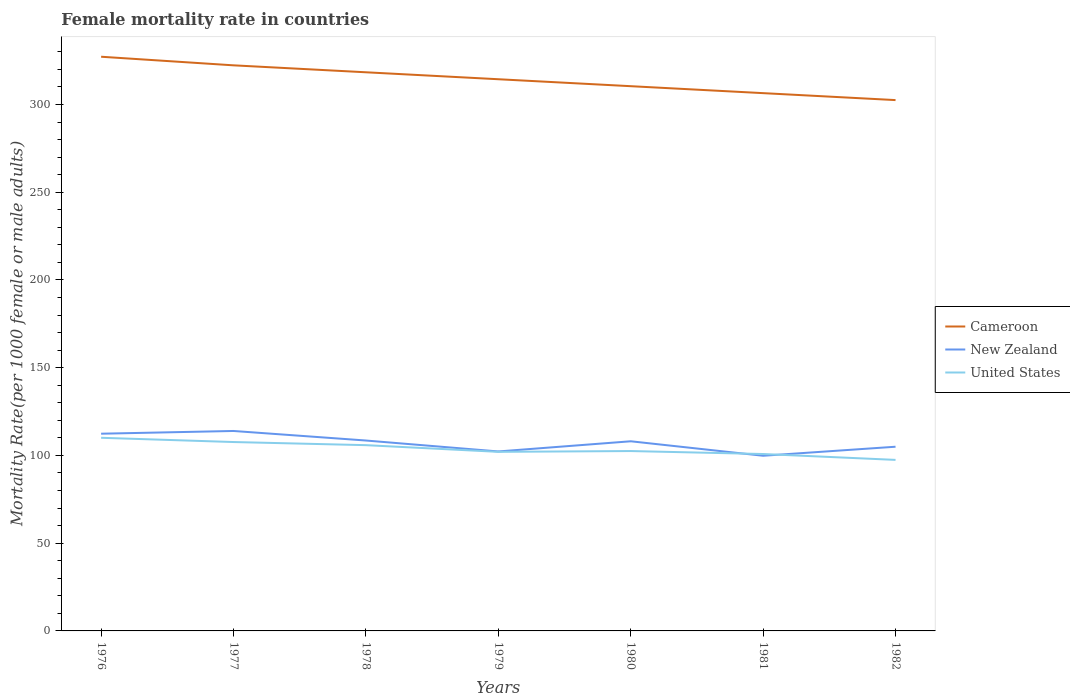How many different coloured lines are there?
Your response must be concise. 3. Across all years, what is the maximum female mortality rate in New Zealand?
Your answer should be compact. 99.83. What is the total female mortality rate in Cameroon in the graph?
Your response must be concise. 24.71. What is the difference between the highest and the second highest female mortality rate in Cameroon?
Provide a short and direct response. 24.71. How many years are there in the graph?
Offer a terse response. 7. What is the difference between two consecutive major ticks on the Y-axis?
Provide a succinct answer. 50. Are the values on the major ticks of Y-axis written in scientific E-notation?
Provide a succinct answer. No. How many legend labels are there?
Provide a succinct answer. 3. How are the legend labels stacked?
Provide a succinct answer. Vertical. What is the title of the graph?
Your answer should be compact. Female mortality rate in countries. What is the label or title of the Y-axis?
Make the answer very short. Mortality Rate(per 1000 female or male adults). What is the Mortality Rate(per 1000 female or male adults) of Cameroon in 1976?
Offer a terse response. 327.22. What is the Mortality Rate(per 1000 female or male adults) in New Zealand in 1976?
Offer a terse response. 112.39. What is the Mortality Rate(per 1000 female or male adults) in United States in 1976?
Your answer should be very brief. 110.07. What is the Mortality Rate(per 1000 female or male adults) in Cameroon in 1977?
Ensure brevity in your answer.  322.32. What is the Mortality Rate(per 1000 female or male adults) in New Zealand in 1977?
Keep it short and to the point. 113.95. What is the Mortality Rate(per 1000 female or male adults) in United States in 1977?
Your answer should be compact. 107.64. What is the Mortality Rate(per 1000 female or male adults) in Cameroon in 1978?
Make the answer very short. 318.36. What is the Mortality Rate(per 1000 female or male adults) of New Zealand in 1978?
Offer a very short reply. 108.51. What is the Mortality Rate(per 1000 female or male adults) in United States in 1978?
Make the answer very short. 105.87. What is the Mortality Rate(per 1000 female or male adults) in Cameroon in 1979?
Provide a succinct answer. 314.39. What is the Mortality Rate(per 1000 female or male adults) in New Zealand in 1979?
Provide a short and direct response. 102.27. What is the Mortality Rate(per 1000 female or male adults) of United States in 1979?
Keep it short and to the point. 102.06. What is the Mortality Rate(per 1000 female or male adults) in Cameroon in 1980?
Offer a very short reply. 310.43. What is the Mortality Rate(per 1000 female or male adults) in New Zealand in 1980?
Ensure brevity in your answer.  108.07. What is the Mortality Rate(per 1000 female or male adults) of United States in 1980?
Your answer should be very brief. 102.51. What is the Mortality Rate(per 1000 female or male adults) of Cameroon in 1981?
Provide a short and direct response. 306.47. What is the Mortality Rate(per 1000 female or male adults) of New Zealand in 1981?
Give a very brief answer. 99.83. What is the Mortality Rate(per 1000 female or male adults) in United States in 1981?
Offer a terse response. 100.82. What is the Mortality Rate(per 1000 female or male adults) in Cameroon in 1982?
Your response must be concise. 302.51. What is the Mortality Rate(per 1000 female or male adults) in New Zealand in 1982?
Give a very brief answer. 104.97. What is the Mortality Rate(per 1000 female or male adults) of United States in 1982?
Provide a short and direct response. 97.47. Across all years, what is the maximum Mortality Rate(per 1000 female or male adults) in Cameroon?
Provide a short and direct response. 327.22. Across all years, what is the maximum Mortality Rate(per 1000 female or male adults) in New Zealand?
Offer a very short reply. 113.95. Across all years, what is the maximum Mortality Rate(per 1000 female or male adults) in United States?
Provide a succinct answer. 110.07. Across all years, what is the minimum Mortality Rate(per 1000 female or male adults) of Cameroon?
Your answer should be very brief. 302.51. Across all years, what is the minimum Mortality Rate(per 1000 female or male adults) in New Zealand?
Ensure brevity in your answer.  99.83. Across all years, what is the minimum Mortality Rate(per 1000 female or male adults) of United States?
Give a very brief answer. 97.47. What is the total Mortality Rate(per 1000 female or male adults) of Cameroon in the graph?
Provide a short and direct response. 2201.7. What is the total Mortality Rate(per 1000 female or male adults) in New Zealand in the graph?
Keep it short and to the point. 749.99. What is the total Mortality Rate(per 1000 female or male adults) of United States in the graph?
Offer a terse response. 726.43. What is the difference between the Mortality Rate(per 1000 female or male adults) of Cameroon in 1976 and that in 1977?
Offer a terse response. 4.9. What is the difference between the Mortality Rate(per 1000 female or male adults) of New Zealand in 1976 and that in 1977?
Give a very brief answer. -1.55. What is the difference between the Mortality Rate(per 1000 female or male adults) of United States in 1976 and that in 1977?
Ensure brevity in your answer.  2.42. What is the difference between the Mortality Rate(per 1000 female or male adults) in Cameroon in 1976 and that in 1978?
Your answer should be very brief. 8.86. What is the difference between the Mortality Rate(per 1000 female or male adults) of New Zealand in 1976 and that in 1978?
Provide a succinct answer. 3.89. What is the difference between the Mortality Rate(per 1000 female or male adults) of United States in 1976 and that in 1978?
Offer a terse response. 4.2. What is the difference between the Mortality Rate(per 1000 female or male adults) of Cameroon in 1976 and that in 1979?
Your response must be concise. 12.83. What is the difference between the Mortality Rate(per 1000 female or male adults) of New Zealand in 1976 and that in 1979?
Offer a very short reply. 10.12. What is the difference between the Mortality Rate(per 1000 female or male adults) in United States in 1976 and that in 1979?
Provide a succinct answer. 8.01. What is the difference between the Mortality Rate(per 1000 female or male adults) of Cameroon in 1976 and that in 1980?
Provide a succinct answer. 16.79. What is the difference between the Mortality Rate(per 1000 female or male adults) of New Zealand in 1976 and that in 1980?
Provide a short and direct response. 4.32. What is the difference between the Mortality Rate(per 1000 female or male adults) in United States in 1976 and that in 1980?
Ensure brevity in your answer.  7.56. What is the difference between the Mortality Rate(per 1000 female or male adults) in Cameroon in 1976 and that in 1981?
Offer a very short reply. 20.75. What is the difference between the Mortality Rate(per 1000 female or male adults) of New Zealand in 1976 and that in 1981?
Provide a succinct answer. 12.57. What is the difference between the Mortality Rate(per 1000 female or male adults) of United States in 1976 and that in 1981?
Provide a short and direct response. 9.25. What is the difference between the Mortality Rate(per 1000 female or male adults) in Cameroon in 1976 and that in 1982?
Make the answer very short. 24.71. What is the difference between the Mortality Rate(per 1000 female or male adults) of New Zealand in 1976 and that in 1982?
Give a very brief answer. 7.42. What is the difference between the Mortality Rate(per 1000 female or male adults) of United States in 1976 and that in 1982?
Provide a succinct answer. 12.6. What is the difference between the Mortality Rate(per 1000 female or male adults) in Cameroon in 1977 and that in 1978?
Ensure brevity in your answer.  3.96. What is the difference between the Mortality Rate(per 1000 female or male adults) of New Zealand in 1977 and that in 1978?
Offer a terse response. 5.44. What is the difference between the Mortality Rate(per 1000 female or male adults) in United States in 1977 and that in 1978?
Ensure brevity in your answer.  1.78. What is the difference between the Mortality Rate(per 1000 female or male adults) in Cameroon in 1977 and that in 1979?
Provide a succinct answer. 7.92. What is the difference between the Mortality Rate(per 1000 female or male adults) of New Zealand in 1977 and that in 1979?
Ensure brevity in your answer.  11.67. What is the difference between the Mortality Rate(per 1000 female or male adults) in United States in 1977 and that in 1979?
Your answer should be very brief. 5.59. What is the difference between the Mortality Rate(per 1000 female or male adults) of Cameroon in 1977 and that in 1980?
Provide a short and direct response. 11.89. What is the difference between the Mortality Rate(per 1000 female or male adults) of New Zealand in 1977 and that in 1980?
Ensure brevity in your answer.  5.87. What is the difference between the Mortality Rate(per 1000 female or male adults) of United States in 1977 and that in 1980?
Provide a short and direct response. 5.13. What is the difference between the Mortality Rate(per 1000 female or male adults) of Cameroon in 1977 and that in 1981?
Your answer should be very brief. 15.85. What is the difference between the Mortality Rate(per 1000 female or male adults) of New Zealand in 1977 and that in 1981?
Ensure brevity in your answer.  14.12. What is the difference between the Mortality Rate(per 1000 female or male adults) in United States in 1977 and that in 1981?
Provide a short and direct response. 6.83. What is the difference between the Mortality Rate(per 1000 female or male adults) in Cameroon in 1977 and that in 1982?
Provide a short and direct response. 19.81. What is the difference between the Mortality Rate(per 1000 female or male adults) in New Zealand in 1977 and that in 1982?
Your answer should be compact. 8.98. What is the difference between the Mortality Rate(per 1000 female or male adults) in United States in 1977 and that in 1982?
Keep it short and to the point. 10.17. What is the difference between the Mortality Rate(per 1000 female or male adults) of Cameroon in 1978 and that in 1979?
Provide a short and direct response. 3.96. What is the difference between the Mortality Rate(per 1000 female or male adults) in New Zealand in 1978 and that in 1979?
Offer a very short reply. 6.23. What is the difference between the Mortality Rate(per 1000 female or male adults) in United States in 1978 and that in 1979?
Your answer should be very brief. 3.81. What is the difference between the Mortality Rate(per 1000 female or male adults) in Cameroon in 1978 and that in 1980?
Provide a succinct answer. 7.92. What is the difference between the Mortality Rate(per 1000 female or male adults) of New Zealand in 1978 and that in 1980?
Offer a very short reply. 0.43. What is the difference between the Mortality Rate(per 1000 female or male adults) of United States in 1978 and that in 1980?
Offer a very short reply. 3.36. What is the difference between the Mortality Rate(per 1000 female or male adults) in Cameroon in 1978 and that in 1981?
Keep it short and to the point. 11.89. What is the difference between the Mortality Rate(per 1000 female or male adults) of New Zealand in 1978 and that in 1981?
Provide a short and direct response. 8.68. What is the difference between the Mortality Rate(per 1000 female or male adults) of United States in 1978 and that in 1981?
Make the answer very short. 5.05. What is the difference between the Mortality Rate(per 1000 female or male adults) in Cameroon in 1978 and that in 1982?
Provide a short and direct response. 15.85. What is the difference between the Mortality Rate(per 1000 female or male adults) in New Zealand in 1978 and that in 1982?
Your response must be concise. 3.54. What is the difference between the Mortality Rate(per 1000 female or male adults) in United States in 1978 and that in 1982?
Your answer should be very brief. 8.4. What is the difference between the Mortality Rate(per 1000 female or male adults) of Cameroon in 1979 and that in 1980?
Offer a very short reply. 3.96. What is the difference between the Mortality Rate(per 1000 female or male adults) in New Zealand in 1979 and that in 1980?
Offer a very short reply. -5.8. What is the difference between the Mortality Rate(per 1000 female or male adults) in United States in 1979 and that in 1980?
Your answer should be very brief. -0.45. What is the difference between the Mortality Rate(per 1000 female or male adults) of Cameroon in 1979 and that in 1981?
Your answer should be compact. 7.92. What is the difference between the Mortality Rate(per 1000 female or male adults) of New Zealand in 1979 and that in 1981?
Give a very brief answer. 2.45. What is the difference between the Mortality Rate(per 1000 female or male adults) in United States in 1979 and that in 1981?
Provide a succinct answer. 1.24. What is the difference between the Mortality Rate(per 1000 female or male adults) in Cameroon in 1979 and that in 1982?
Your response must be concise. 11.89. What is the difference between the Mortality Rate(per 1000 female or male adults) of New Zealand in 1979 and that in 1982?
Provide a short and direct response. -2.7. What is the difference between the Mortality Rate(per 1000 female or male adults) in United States in 1979 and that in 1982?
Your response must be concise. 4.59. What is the difference between the Mortality Rate(per 1000 female or male adults) of Cameroon in 1980 and that in 1981?
Ensure brevity in your answer.  3.96. What is the difference between the Mortality Rate(per 1000 female or male adults) of New Zealand in 1980 and that in 1981?
Your answer should be compact. 8.25. What is the difference between the Mortality Rate(per 1000 female or male adults) in United States in 1980 and that in 1981?
Offer a terse response. 1.69. What is the difference between the Mortality Rate(per 1000 female or male adults) of Cameroon in 1980 and that in 1982?
Ensure brevity in your answer.  7.92. What is the difference between the Mortality Rate(per 1000 female or male adults) in New Zealand in 1980 and that in 1982?
Offer a terse response. 3.1. What is the difference between the Mortality Rate(per 1000 female or male adults) in United States in 1980 and that in 1982?
Your answer should be very brief. 5.04. What is the difference between the Mortality Rate(per 1000 female or male adults) in Cameroon in 1981 and that in 1982?
Provide a succinct answer. 3.96. What is the difference between the Mortality Rate(per 1000 female or male adults) of New Zealand in 1981 and that in 1982?
Ensure brevity in your answer.  -5.14. What is the difference between the Mortality Rate(per 1000 female or male adults) of United States in 1981 and that in 1982?
Offer a very short reply. 3.35. What is the difference between the Mortality Rate(per 1000 female or male adults) of Cameroon in 1976 and the Mortality Rate(per 1000 female or male adults) of New Zealand in 1977?
Ensure brevity in your answer.  213.27. What is the difference between the Mortality Rate(per 1000 female or male adults) in Cameroon in 1976 and the Mortality Rate(per 1000 female or male adults) in United States in 1977?
Your response must be concise. 219.58. What is the difference between the Mortality Rate(per 1000 female or male adults) in New Zealand in 1976 and the Mortality Rate(per 1000 female or male adults) in United States in 1977?
Ensure brevity in your answer.  4.75. What is the difference between the Mortality Rate(per 1000 female or male adults) of Cameroon in 1976 and the Mortality Rate(per 1000 female or male adults) of New Zealand in 1978?
Your response must be concise. 218.71. What is the difference between the Mortality Rate(per 1000 female or male adults) in Cameroon in 1976 and the Mortality Rate(per 1000 female or male adults) in United States in 1978?
Give a very brief answer. 221.35. What is the difference between the Mortality Rate(per 1000 female or male adults) in New Zealand in 1976 and the Mortality Rate(per 1000 female or male adults) in United States in 1978?
Give a very brief answer. 6.53. What is the difference between the Mortality Rate(per 1000 female or male adults) in Cameroon in 1976 and the Mortality Rate(per 1000 female or male adults) in New Zealand in 1979?
Make the answer very short. 224.95. What is the difference between the Mortality Rate(per 1000 female or male adults) in Cameroon in 1976 and the Mortality Rate(per 1000 female or male adults) in United States in 1979?
Your response must be concise. 225.16. What is the difference between the Mortality Rate(per 1000 female or male adults) of New Zealand in 1976 and the Mortality Rate(per 1000 female or male adults) of United States in 1979?
Make the answer very short. 10.34. What is the difference between the Mortality Rate(per 1000 female or male adults) in Cameroon in 1976 and the Mortality Rate(per 1000 female or male adults) in New Zealand in 1980?
Ensure brevity in your answer.  219.15. What is the difference between the Mortality Rate(per 1000 female or male adults) in Cameroon in 1976 and the Mortality Rate(per 1000 female or male adults) in United States in 1980?
Your answer should be compact. 224.71. What is the difference between the Mortality Rate(per 1000 female or male adults) of New Zealand in 1976 and the Mortality Rate(per 1000 female or male adults) of United States in 1980?
Make the answer very short. 9.88. What is the difference between the Mortality Rate(per 1000 female or male adults) in Cameroon in 1976 and the Mortality Rate(per 1000 female or male adults) in New Zealand in 1981?
Ensure brevity in your answer.  227.39. What is the difference between the Mortality Rate(per 1000 female or male adults) in Cameroon in 1976 and the Mortality Rate(per 1000 female or male adults) in United States in 1981?
Offer a very short reply. 226.4. What is the difference between the Mortality Rate(per 1000 female or male adults) in New Zealand in 1976 and the Mortality Rate(per 1000 female or male adults) in United States in 1981?
Ensure brevity in your answer.  11.58. What is the difference between the Mortality Rate(per 1000 female or male adults) in Cameroon in 1976 and the Mortality Rate(per 1000 female or male adults) in New Zealand in 1982?
Offer a terse response. 222.25. What is the difference between the Mortality Rate(per 1000 female or male adults) in Cameroon in 1976 and the Mortality Rate(per 1000 female or male adults) in United States in 1982?
Provide a short and direct response. 229.75. What is the difference between the Mortality Rate(per 1000 female or male adults) in New Zealand in 1976 and the Mortality Rate(per 1000 female or male adults) in United States in 1982?
Give a very brief answer. 14.93. What is the difference between the Mortality Rate(per 1000 female or male adults) of Cameroon in 1977 and the Mortality Rate(per 1000 female or male adults) of New Zealand in 1978?
Provide a succinct answer. 213.81. What is the difference between the Mortality Rate(per 1000 female or male adults) in Cameroon in 1977 and the Mortality Rate(per 1000 female or male adults) in United States in 1978?
Your response must be concise. 216.45. What is the difference between the Mortality Rate(per 1000 female or male adults) in New Zealand in 1977 and the Mortality Rate(per 1000 female or male adults) in United States in 1978?
Ensure brevity in your answer.  8.08. What is the difference between the Mortality Rate(per 1000 female or male adults) in Cameroon in 1977 and the Mortality Rate(per 1000 female or male adults) in New Zealand in 1979?
Give a very brief answer. 220.04. What is the difference between the Mortality Rate(per 1000 female or male adults) in Cameroon in 1977 and the Mortality Rate(per 1000 female or male adults) in United States in 1979?
Your answer should be compact. 220.26. What is the difference between the Mortality Rate(per 1000 female or male adults) of New Zealand in 1977 and the Mortality Rate(per 1000 female or male adults) of United States in 1979?
Your response must be concise. 11.89. What is the difference between the Mortality Rate(per 1000 female or male adults) in Cameroon in 1977 and the Mortality Rate(per 1000 female or male adults) in New Zealand in 1980?
Make the answer very short. 214.24. What is the difference between the Mortality Rate(per 1000 female or male adults) of Cameroon in 1977 and the Mortality Rate(per 1000 female or male adults) of United States in 1980?
Provide a short and direct response. 219.81. What is the difference between the Mortality Rate(per 1000 female or male adults) of New Zealand in 1977 and the Mortality Rate(per 1000 female or male adults) of United States in 1980?
Keep it short and to the point. 11.44. What is the difference between the Mortality Rate(per 1000 female or male adults) of Cameroon in 1977 and the Mortality Rate(per 1000 female or male adults) of New Zealand in 1981?
Provide a succinct answer. 222.49. What is the difference between the Mortality Rate(per 1000 female or male adults) of Cameroon in 1977 and the Mortality Rate(per 1000 female or male adults) of United States in 1981?
Your response must be concise. 221.5. What is the difference between the Mortality Rate(per 1000 female or male adults) of New Zealand in 1977 and the Mortality Rate(per 1000 female or male adults) of United States in 1981?
Your answer should be very brief. 13.13. What is the difference between the Mortality Rate(per 1000 female or male adults) in Cameroon in 1977 and the Mortality Rate(per 1000 female or male adults) in New Zealand in 1982?
Offer a very short reply. 217.35. What is the difference between the Mortality Rate(per 1000 female or male adults) in Cameroon in 1977 and the Mortality Rate(per 1000 female or male adults) in United States in 1982?
Your answer should be very brief. 224.85. What is the difference between the Mortality Rate(per 1000 female or male adults) of New Zealand in 1977 and the Mortality Rate(per 1000 female or male adults) of United States in 1982?
Make the answer very short. 16.48. What is the difference between the Mortality Rate(per 1000 female or male adults) in Cameroon in 1978 and the Mortality Rate(per 1000 female or male adults) in New Zealand in 1979?
Keep it short and to the point. 216.08. What is the difference between the Mortality Rate(per 1000 female or male adults) of Cameroon in 1978 and the Mortality Rate(per 1000 female or male adults) of United States in 1979?
Your answer should be compact. 216.3. What is the difference between the Mortality Rate(per 1000 female or male adults) of New Zealand in 1978 and the Mortality Rate(per 1000 female or male adults) of United States in 1979?
Give a very brief answer. 6.45. What is the difference between the Mortality Rate(per 1000 female or male adults) of Cameroon in 1978 and the Mortality Rate(per 1000 female or male adults) of New Zealand in 1980?
Provide a succinct answer. 210.28. What is the difference between the Mortality Rate(per 1000 female or male adults) of Cameroon in 1978 and the Mortality Rate(per 1000 female or male adults) of United States in 1980?
Your answer should be very brief. 215.85. What is the difference between the Mortality Rate(per 1000 female or male adults) of New Zealand in 1978 and the Mortality Rate(per 1000 female or male adults) of United States in 1980?
Offer a very short reply. 6. What is the difference between the Mortality Rate(per 1000 female or male adults) in Cameroon in 1978 and the Mortality Rate(per 1000 female or male adults) in New Zealand in 1981?
Offer a terse response. 218.53. What is the difference between the Mortality Rate(per 1000 female or male adults) in Cameroon in 1978 and the Mortality Rate(per 1000 female or male adults) in United States in 1981?
Offer a very short reply. 217.54. What is the difference between the Mortality Rate(per 1000 female or male adults) of New Zealand in 1978 and the Mortality Rate(per 1000 female or male adults) of United States in 1981?
Offer a very short reply. 7.69. What is the difference between the Mortality Rate(per 1000 female or male adults) of Cameroon in 1978 and the Mortality Rate(per 1000 female or male adults) of New Zealand in 1982?
Your answer should be very brief. 213.39. What is the difference between the Mortality Rate(per 1000 female or male adults) of Cameroon in 1978 and the Mortality Rate(per 1000 female or male adults) of United States in 1982?
Ensure brevity in your answer.  220.89. What is the difference between the Mortality Rate(per 1000 female or male adults) of New Zealand in 1978 and the Mortality Rate(per 1000 female or male adults) of United States in 1982?
Your response must be concise. 11.04. What is the difference between the Mortality Rate(per 1000 female or male adults) in Cameroon in 1979 and the Mortality Rate(per 1000 female or male adults) in New Zealand in 1980?
Your answer should be compact. 206.32. What is the difference between the Mortality Rate(per 1000 female or male adults) in Cameroon in 1979 and the Mortality Rate(per 1000 female or male adults) in United States in 1980?
Your answer should be very brief. 211.88. What is the difference between the Mortality Rate(per 1000 female or male adults) of New Zealand in 1979 and the Mortality Rate(per 1000 female or male adults) of United States in 1980?
Provide a succinct answer. -0.24. What is the difference between the Mortality Rate(per 1000 female or male adults) in Cameroon in 1979 and the Mortality Rate(per 1000 female or male adults) in New Zealand in 1981?
Offer a terse response. 214.57. What is the difference between the Mortality Rate(per 1000 female or male adults) of Cameroon in 1979 and the Mortality Rate(per 1000 female or male adults) of United States in 1981?
Your answer should be very brief. 213.58. What is the difference between the Mortality Rate(per 1000 female or male adults) in New Zealand in 1979 and the Mortality Rate(per 1000 female or male adults) in United States in 1981?
Make the answer very short. 1.46. What is the difference between the Mortality Rate(per 1000 female or male adults) of Cameroon in 1979 and the Mortality Rate(per 1000 female or male adults) of New Zealand in 1982?
Offer a terse response. 209.42. What is the difference between the Mortality Rate(per 1000 female or male adults) in Cameroon in 1979 and the Mortality Rate(per 1000 female or male adults) in United States in 1982?
Give a very brief answer. 216.92. What is the difference between the Mortality Rate(per 1000 female or male adults) in New Zealand in 1979 and the Mortality Rate(per 1000 female or male adults) in United States in 1982?
Give a very brief answer. 4.8. What is the difference between the Mortality Rate(per 1000 female or male adults) of Cameroon in 1980 and the Mortality Rate(per 1000 female or male adults) of New Zealand in 1981?
Provide a short and direct response. 210.6. What is the difference between the Mortality Rate(per 1000 female or male adults) of Cameroon in 1980 and the Mortality Rate(per 1000 female or male adults) of United States in 1981?
Keep it short and to the point. 209.62. What is the difference between the Mortality Rate(per 1000 female or male adults) in New Zealand in 1980 and the Mortality Rate(per 1000 female or male adults) in United States in 1981?
Your answer should be compact. 7.26. What is the difference between the Mortality Rate(per 1000 female or male adults) in Cameroon in 1980 and the Mortality Rate(per 1000 female or male adults) in New Zealand in 1982?
Your answer should be compact. 205.46. What is the difference between the Mortality Rate(per 1000 female or male adults) in Cameroon in 1980 and the Mortality Rate(per 1000 female or male adults) in United States in 1982?
Provide a short and direct response. 212.96. What is the difference between the Mortality Rate(per 1000 female or male adults) in New Zealand in 1980 and the Mortality Rate(per 1000 female or male adults) in United States in 1982?
Offer a very short reply. 10.6. What is the difference between the Mortality Rate(per 1000 female or male adults) in Cameroon in 1981 and the Mortality Rate(per 1000 female or male adults) in New Zealand in 1982?
Offer a terse response. 201.5. What is the difference between the Mortality Rate(per 1000 female or male adults) in Cameroon in 1981 and the Mortality Rate(per 1000 female or male adults) in United States in 1982?
Provide a succinct answer. 209. What is the difference between the Mortality Rate(per 1000 female or male adults) of New Zealand in 1981 and the Mortality Rate(per 1000 female or male adults) of United States in 1982?
Offer a very short reply. 2.36. What is the average Mortality Rate(per 1000 female or male adults) of Cameroon per year?
Your answer should be compact. 314.53. What is the average Mortality Rate(per 1000 female or male adults) of New Zealand per year?
Ensure brevity in your answer.  107.14. What is the average Mortality Rate(per 1000 female or male adults) of United States per year?
Your response must be concise. 103.78. In the year 1976, what is the difference between the Mortality Rate(per 1000 female or male adults) of Cameroon and Mortality Rate(per 1000 female or male adults) of New Zealand?
Your answer should be very brief. 214.82. In the year 1976, what is the difference between the Mortality Rate(per 1000 female or male adults) of Cameroon and Mortality Rate(per 1000 female or male adults) of United States?
Ensure brevity in your answer.  217.15. In the year 1976, what is the difference between the Mortality Rate(per 1000 female or male adults) of New Zealand and Mortality Rate(per 1000 female or male adults) of United States?
Offer a very short reply. 2.33. In the year 1977, what is the difference between the Mortality Rate(per 1000 female or male adults) in Cameroon and Mortality Rate(per 1000 female or male adults) in New Zealand?
Make the answer very short. 208.37. In the year 1977, what is the difference between the Mortality Rate(per 1000 female or male adults) in Cameroon and Mortality Rate(per 1000 female or male adults) in United States?
Your answer should be very brief. 214.68. In the year 1977, what is the difference between the Mortality Rate(per 1000 female or male adults) of New Zealand and Mortality Rate(per 1000 female or male adults) of United States?
Your response must be concise. 6.3. In the year 1978, what is the difference between the Mortality Rate(per 1000 female or male adults) in Cameroon and Mortality Rate(per 1000 female or male adults) in New Zealand?
Ensure brevity in your answer.  209.85. In the year 1978, what is the difference between the Mortality Rate(per 1000 female or male adults) in Cameroon and Mortality Rate(per 1000 female or male adults) in United States?
Offer a terse response. 212.49. In the year 1978, what is the difference between the Mortality Rate(per 1000 female or male adults) in New Zealand and Mortality Rate(per 1000 female or male adults) in United States?
Keep it short and to the point. 2.64. In the year 1979, what is the difference between the Mortality Rate(per 1000 female or male adults) of Cameroon and Mortality Rate(per 1000 female or male adults) of New Zealand?
Your answer should be compact. 212.12. In the year 1979, what is the difference between the Mortality Rate(per 1000 female or male adults) in Cameroon and Mortality Rate(per 1000 female or male adults) in United States?
Provide a succinct answer. 212.34. In the year 1979, what is the difference between the Mortality Rate(per 1000 female or male adults) in New Zealand and Mortality Rate(per 1000 female or male adults) in United States?
Keep it short and to the point. 0.22. In the year 1980, what is the difference between the Mortality Rate(per 1000 female or male adults) in Cameroon and Mortality Rate(per 1000 female or male adults) in New Zealand?
Offer a terse response. 202.36. In the year 1980, what is the difference between the Mortality Rate(per 1000 female or male adults) of Cameroon and Mortality Rate(per 1000 female or male adults) of United States?
Your answer should be compact. 207.92. In the year 1980, what is the difference between the Mortality Rate(per 1000 female or male adults) of New Zealand and Mortality Rate(per 1000 female or male adults) of United States?
Offer a terse response. 5.56. In the year 1981, what is the difference between the Mortality Rate(per 1000 female or male adults) of Cameroon and Mortality Rate(per 1000 female or male adults) of New Zealand?
Offer a terse response. 206.64. In the year 1981, what is the difference between the Mortality Rate(per 1000 female or male adults) of Cameroon and Mortality Rate(per 1000 female or male adults) of United States?
Make the answer very short. 205.65. In the year 1981, what is the difference between the Mortality Rate(per 1000 female or male adults) in New Zealand and Mortality Rate(per 1000 female or male adults) in United States?
Offer a terse response. -0.99. In the year 1982, what is the difference between the Mortality Rate(per 1000 female or male adults) in Cameroon and Mortality Rate(per 1000 female or male adults) in New Zealand?
Keep it short and to the point. 197.54. In the year 1982, what is the difference between the Mortality Rate(per 1000 female or male adults) in Cameroon and Mortality Rate(per 1000 female or male adults) in United States?
Your answer should be compact. 205.04. What is the ratio of the Mortality Rate(per 1000 female or male adults) in Cameroon in 1976 to that in 1977?
Offer a terse response. 1.02. What is the ratio of the Mortality Rate(per 1000 female or male adults) of New Zealand in 1976 to that in 1977?
Make the answer very short. 0.99. What is the ratio of the Mortality Rate(per 1000 female or male adults) in United States in 1976 to that in 1977?
Your answer should be very brief. 1.02. What is the ratio of the Mortality Rate(per 1000 female or male adults) of Cameroon in 1976 to that in 1978?
Provide a short and direct response. 1.03. What is the ratio of the Mortality Rate(per 1000 female or male adults) in New Zealand in 1976 to that in 1978?
Keep it short and to the point. 1.04. What is the ratio of the Mortality Rate(per 1000 female or male adults) in United States in 1976 to that in 1978?
Your response must be concise. 1.04. What is the ratio of the Mortality Rate(per 1000 female or male adults) of Cameroon in 1976 to that in 1979?
Ensure brevity in your answer.  1.04. What is the ratio of the Mortality Rate(per 1000 female or male adults) of New Zealand in 1976 to that in 1979?
Your answer should be compact. 1.1. What is the ratio of the Mortality Rate(per 1000 female or male adults) in United States in 1976 to that in 1979?
Offer a very short reply. 1.08. What is the ratio of the Mortality Rate(per 1000 female or male adults) in Cameroon in 1976 to that in 1980?
Your response must be concise. 1.05. What is the ratio of the Mortality Rate(per 1000 female or male adults) of United States in 1976 to that in 1980?
Ensure brevity in your answer.  1.07. What is the ratio of the Mortality Rate(per 1000 female or male adults) in Cameroon in 1976 to that in 1981?
Your answer should be compact. 1.07. What is the ratio of the Mortality Rate(per 1000 female or male adults) of New Zealand in 1976 to that in 1981?
Ensure brevity in your answer.  1.13. What is the ratio of the Mortality Rate(per 1000 female or male adults) of United States in 1976 to that in 1981?
Provide a short and direct response. 1.09. What is the ratio of the Mortality Rate(per 1000 female or male adults) in Cameroon in 1976 to that in 1982?
Offer a very short reply. 1.08. What is the ratio of the Mortality Rate(per 1000 female or male adults) of New Zealand in 1976 to that in 1982?
Your answer should be very brief. 1.07. What is the ratio of the Mortality Rate(per 1000 female or male adults) in United States in 1976 to that in 1982?
Provide a short and direct response. 1.13. What is the ratio of the Mortality Rate(per 1000 female or male adults) in Cameroon in 1977 to that in 1978?
Make the answer very short. 1.01. What is the ratio of the Mortality Rate(per 1000 female or male adults) in New Zealand in 1977 to that in 1978?
Your answer should be compact. 1.05. What is the ratio of the Mortality Rate(per 1000 female or male adults) in United States in 1977 to that in 1978?
Ensure brevity in your answer.  1.02. What is the ratio of the Mortality Rate(per 1000 female or male adults) of Cameroon in 1977 to that in 1979?
Your answer should be very brief. 1.03. What is the ratio of the Mortality Rate(per 1000 female or male adults) in New Zealand in 1977 to that in 1979?
Provide a succinct answer. 1.11. What is the ratio of the Mortality Rate(per 1000 female or male adults) of United States in 1977 to that in 1979?
Offer a terse response. 1.05. What is the ratio of the Mortality Rate(per 1000 female or male adults) in Cameroon in 1977 to that in 1980?
Your answer should be very brief. 1.04. What is the ratio of the Mortality Rate(per 1000 female or male adults) in New Zealand in 1977 to that in 1980?
Ensure brevity in your answer.  1.05. What is the ratio of the Mortality Rate(per 1000 female or male adults) of United States in 1977 to that in 1980?
Your answer should be very brief. 1.05. What is the ratio of the Mortality Rate(per 1000 female or male adults) of Cameroon in 1977 to that in 1981?
Your response must be concise. 1.05. What is the ratio of the Mortality Rate(per 1000 female or male adults) of New Zealand in 1977 to that in 1981?
Provide a succinct answer. 1.14. What is the ratio of the Mortality Rate(per 1000 female or male adults) of United States in 1977 to that in 1981?
Provide a succinct answer. 1.07. What is the ratio of the Mortality Rate(per 1000 female or male adults) of Cameroon in 1977 to that in 1982?
Make the answer very short. 1.07. What is the ratio of the Mortality Rate(per 1000 female or male adults) of New Zealand in 1977 to that in 1982?
Provide a succinct answer. 1.09. What is the ratio of the Mortality Rate(per 1000 female or male adults) in United States in 1977 to that in 1982?
Your answer should be very brief. 1.1. What is the ratio of the Mortality Rate(per 1000 female or male adults) of Cameroon in 1978 to that in 1979?
Provide a succinct answer. 1.01. What is the ratio of the Mortality Rate(per 1000 female or male adults) in New Zealand in 1978 to that in 1979?
Ensure brevity in your answer.  1.06. What is the ratio of the Mortality Rate(per 1000 female or male adults) of United States in 1978 to that in 1979?
Your answer should be compact. 1.04. What is the ratio of the Mortality Rate(per 1000 female or male adults) of Cameroon in 1978 to that in 1980?
Offer a terse response. 1.03. What is the ratio of the Mortality Rate(per 1000 female or male adults) of United States in 1978 to that in 1980?
Keep it short and to the point. 1.03. What is the ratio of the Mortality Rate(per 1000 female or male adults) of Cameroon in 1978 to that in 1981?
Your answer should be very brief. 1.04. What is the ratio of the Mortality Rate(per 1000 female or male adults) in New Zealand in 1978 to that in 1981?
Offer a very short reply. 1.09. What is the ratio of the Mortality Rate(per 1000 female or male adults) in United States in 1978 to that in 1981?
Ensure brevity in your answer.  1.05. What is the ratio of the Mortality Rate(per 1000 female or male adults) in Cameroon in 1978 to that in 1982?
Provide a succinct answer. 1.05. What is the ratio of the Mortality Rate(per 1000 female or male adults) of New Zealand in 1978 to that in 1982?
Your answer should be very brief. 1.03. What is the ratio of the Mortality Rate(per 1000 female or male adults) of United States in 1978 to that in 1982?
Your response must be concise. 1.09. What is the ratio of the Mortality Rate(per 1000 female or male adults) in Cameroon in 1979 to that in 1980?
Your response must be concise. 1.01. What is the ratio of the Mortality Rate(per 1000 female or male adults) in New Zealand in 1979 to that in 1980?
Your answer should be very brief. 0.95. What is the ratio of the Mortality Rate(per 1000 female or male adults) in Cameroon in 1979 to that in 1981?
Provide a short and direct response. 1.03. What is the ratio of the Mortality Rate(per 1000 female or male adults) of New Zealand in 1979 to that in 1981?
Offer a terse response. 1.02. What is the ratio of the Mortality Rate(per 1000 female or male adults) of United States in 1979 to that in 1981?
Ensure brevity in your answer.  1.01. What is the ratio of the Mortality Rate(per 1000 female or male adults) of Cameroon in 1979 to that in 1982?
Give a very brief answer. 1.04. What is the ratio of the Mortality Rate(per 1000 female or male adults) in New Zealand in 1979 to that in 1982?
Your answer should be compact. 0.97. What is the ratio of the Mortality Rate(per 1000 female or male adults) in United States in 1979 to that in 1982?
Make the answer very short. 1.05. What is the ratio of the Mortality Rate(per 1000 female or male adults) in Cameroon in 1980 to that in 1981?
Offer a terse response. 1.01. What is the ratio of the Mortality Rate(per 1000 female or male adults) of New Zealand in 1980 to that in 1981?
Provide a succinct answer. 1.08. What is the ratio of the Mortality Rate(per 1000 female or male adults) of United States in 1980 to that in 1981?
Give a very brief answer. 1.02. What is the ratio of the Mortality Rate(per 1000 female or male adults) in Cameroon in 1980 to that in 1982?
Make the answer very short. 1.03. What is the ratio of the Mortality Rate(per 1000 female or male adults) of New Zealand in 1980 to that in 1982?
Your answer should be very brief. 1.03. What is the ratio of the Mortality Rate(per 1000 female or male adults) in United States in 1980 to that in 1982?
Offer a terse response. 1.05. What is the ratio of the Mortality Rate(per 1000 female or male adults) in Cameroon in 1981 to that in 1982?
Offer a very short reply. 1.01. What is the ratio of the Mortality Rate(per 1000 female or male adults) in New Zealand in 1981 to that in 1982?
Offer a terse response. 0.95. What is the ratio of the Mortality Rate(per 1000 female or male adults) in United States in 1981 to that in 1982?
Give a very brief answer. 1.03. What is the difference between the highest and the second highest Mortality Rate(per 1000 female or male adults) of Cameroon?
Give a very brief answer. 4.9. What is the difference between the highest and the second highest Mortality Rate(per 1000 female or male adults) in New Zealand?
Your answer should be very brief. 1.55. What is the difference between the highest and the second highest Mortality Rate(per 1000 female or male adults) of United States?
Keep it short and to the point. 2.42. What is the difference between the highest and the lowest Mortality Rate(per 1000 female or male adults) of Cameroon?
Your response must be concise. 24.71. What is the difference between the highest and the lowest Mortality Rate(per 1000 female or male adults) in New Zealand?
Offer a terse response. 14.12. What is the difference between the highest and the lowest Mortality Rate(per 1000 female or male adults) in United States?
Provide a short and direct response. 12.6. 